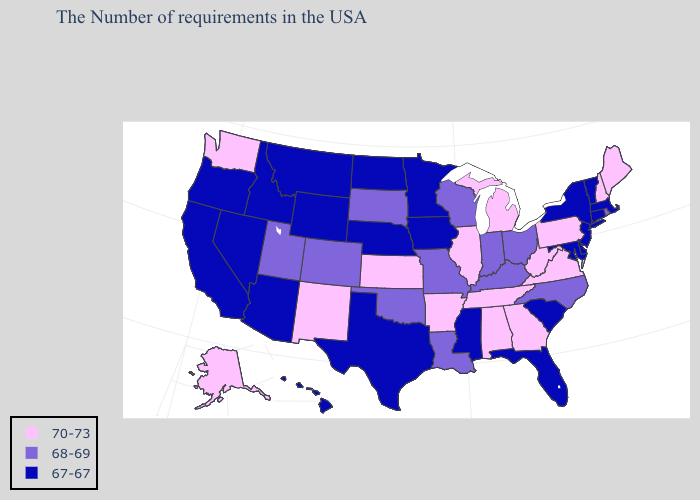Among the states that border Utah , which have the highest value?
Be succinct. New Mexico. What is the highest value in the USA?
Write a very short answer. 70-73. What is the value of South Dakota?
Answer briefly. 68-69. What is the value of Alabama?
Keep it brief. 70-73. Name the states that have a value in the range 70-73?
Answer briefly. Maine, New Hampshire, Pennsylvania, Virginia, West Virginia, Georgia, Michigan, Alabama, Tennessee, Illinois, Arkansas, Kansas, New Mexico, Washington, Alaska. What is the value of Georgia?
Write a very short answer. 70-73. What is the value of Minnesota?
Be succinct. 67-67. Does the map have missing data?
Be succinct. No. What is the value of Iowa?
Keep it brief. 67-67. Name the states that have a value in the range 67-67?
Concise answer only. Massachusetts, Vermont, Connecticut, New York, New Jersey, Delaware, Maryland, South Carolina, Florida, Mississippi, Minnesota, Iowa, Nebraska, Texas, North Dakota, Wyoming, Montana, Arizona, Idaho, Nevada, California, Oregon, Hawaii. Is the legend a continuous bar?
Give a very brief answer. No. Does the map have missing data?
Write a very short answer. No. Name the states that have a value in the range 68-69?
Give a very brief answer. Rhode Island, North Carolina, Ohio, Kentucky, Indiana, Wisconsin, Louisiana, Missouri, Oklahoma, South Dakota, Colorado, Utah. Is the legend a continuous bar?
Give a very brief answer. No. Does Massachusetts have the lowest value in the Northeast?
Concise answer only. Yes. 